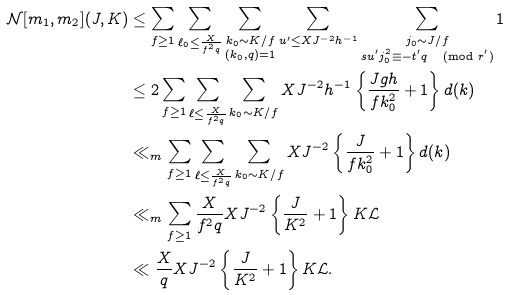<formula> <loc_0><loc_0><loc_500><loc_500>\mathcal { N } [ m _ { 1 } , m _ { 2 } ] ( J , K ) & \leq \sum _ { f \geq 1 } \sum _ { \ell _ { 0 } \leq \frac { X } { f ^ { 2 } q } } \sum _ { \substack { k _ { 0 } \sim K / f \\ ( k _ { 0 } , q ) = 1 } } \sum _ { u ^ { \prime } \leq X J ^ { - 2 } h ^ { - 1 } } \sum _ { \substack { j _ { 0 } \sim J / f \\ s u ^ { \prime } j _ { 0 } ^ { 2 } \equiv - t ^ { \prime } q \, \pmod { r ^ { \prime } } } } 1 \\ & \leq 2 \sum _ { f \geq 1 } \sum _ { \ell \leq \frac { X } { f ^ { 2 } q } } \sum _ { k _ { 0 } \sim K / f } X J ^ { - 2 } h ^ { - 1 } \left \{ \frac { J g h } { f k _ { 0 } ^ { 2 } } + 1 \right \} d ( k ) \\ & \ll _ { m } \sum _ { f \geq 1 } \sum _ { \ell \leq \frac { X } { f ^ { 2 } q } } \sum _ { k _ { 0 } \sim K / f } X J ^ { - 2 } \left \{ \frac { J } { f k _ { 0 } ^ { 2 } } + 1 \right \} d ( k ) \\ & \ll _ { m } \sum _ { f \geq 1 } \frac { X } { f ^ { 2 } q } X J ^ { - 2 } \left \{ \frac { J } { K ^ { 2 } } + 1 \right \} K \mathcal { L } \\ & \ll \frac { X } { q } X J ^ { - 2 } \left \{ \frac { J } { K ^ { 2 } } + 1 \right \} K \mathcal { L } .</formula> 